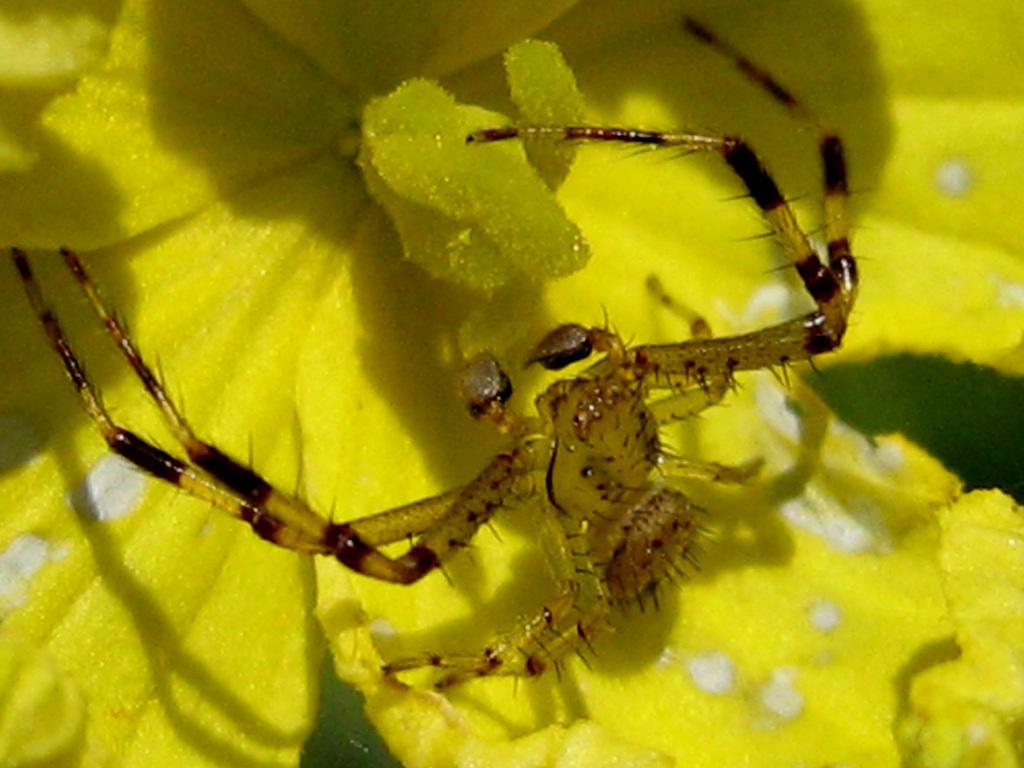Describe this image in one or two sentences. In this image there is an insect on a flower. In front of the insect there are pollen grains. In the background there are petals of the flower. 